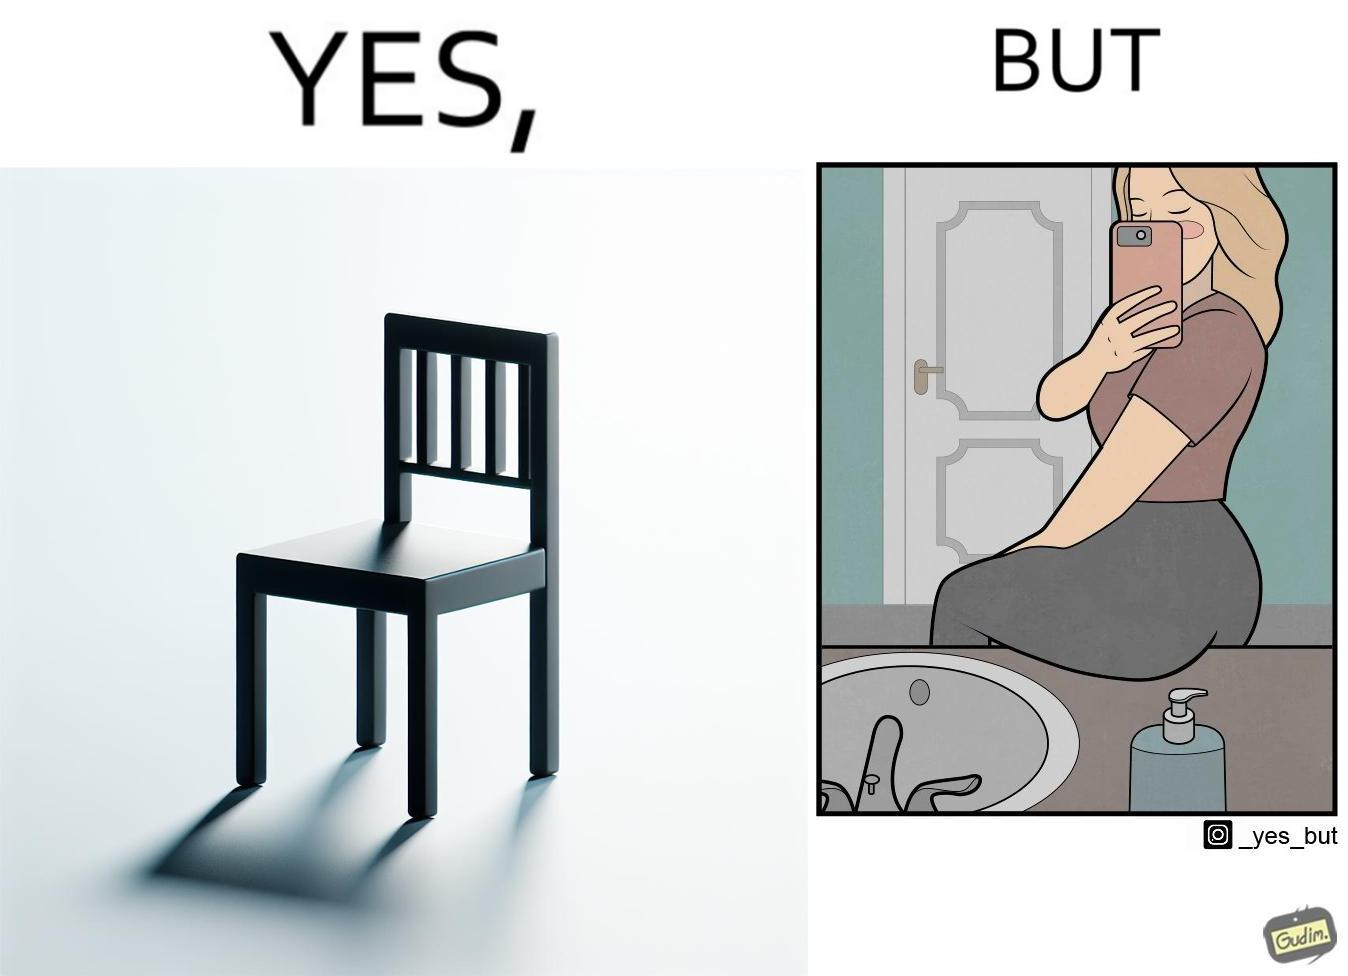Is there satirical content in this image? Yes, this image is satirical. 